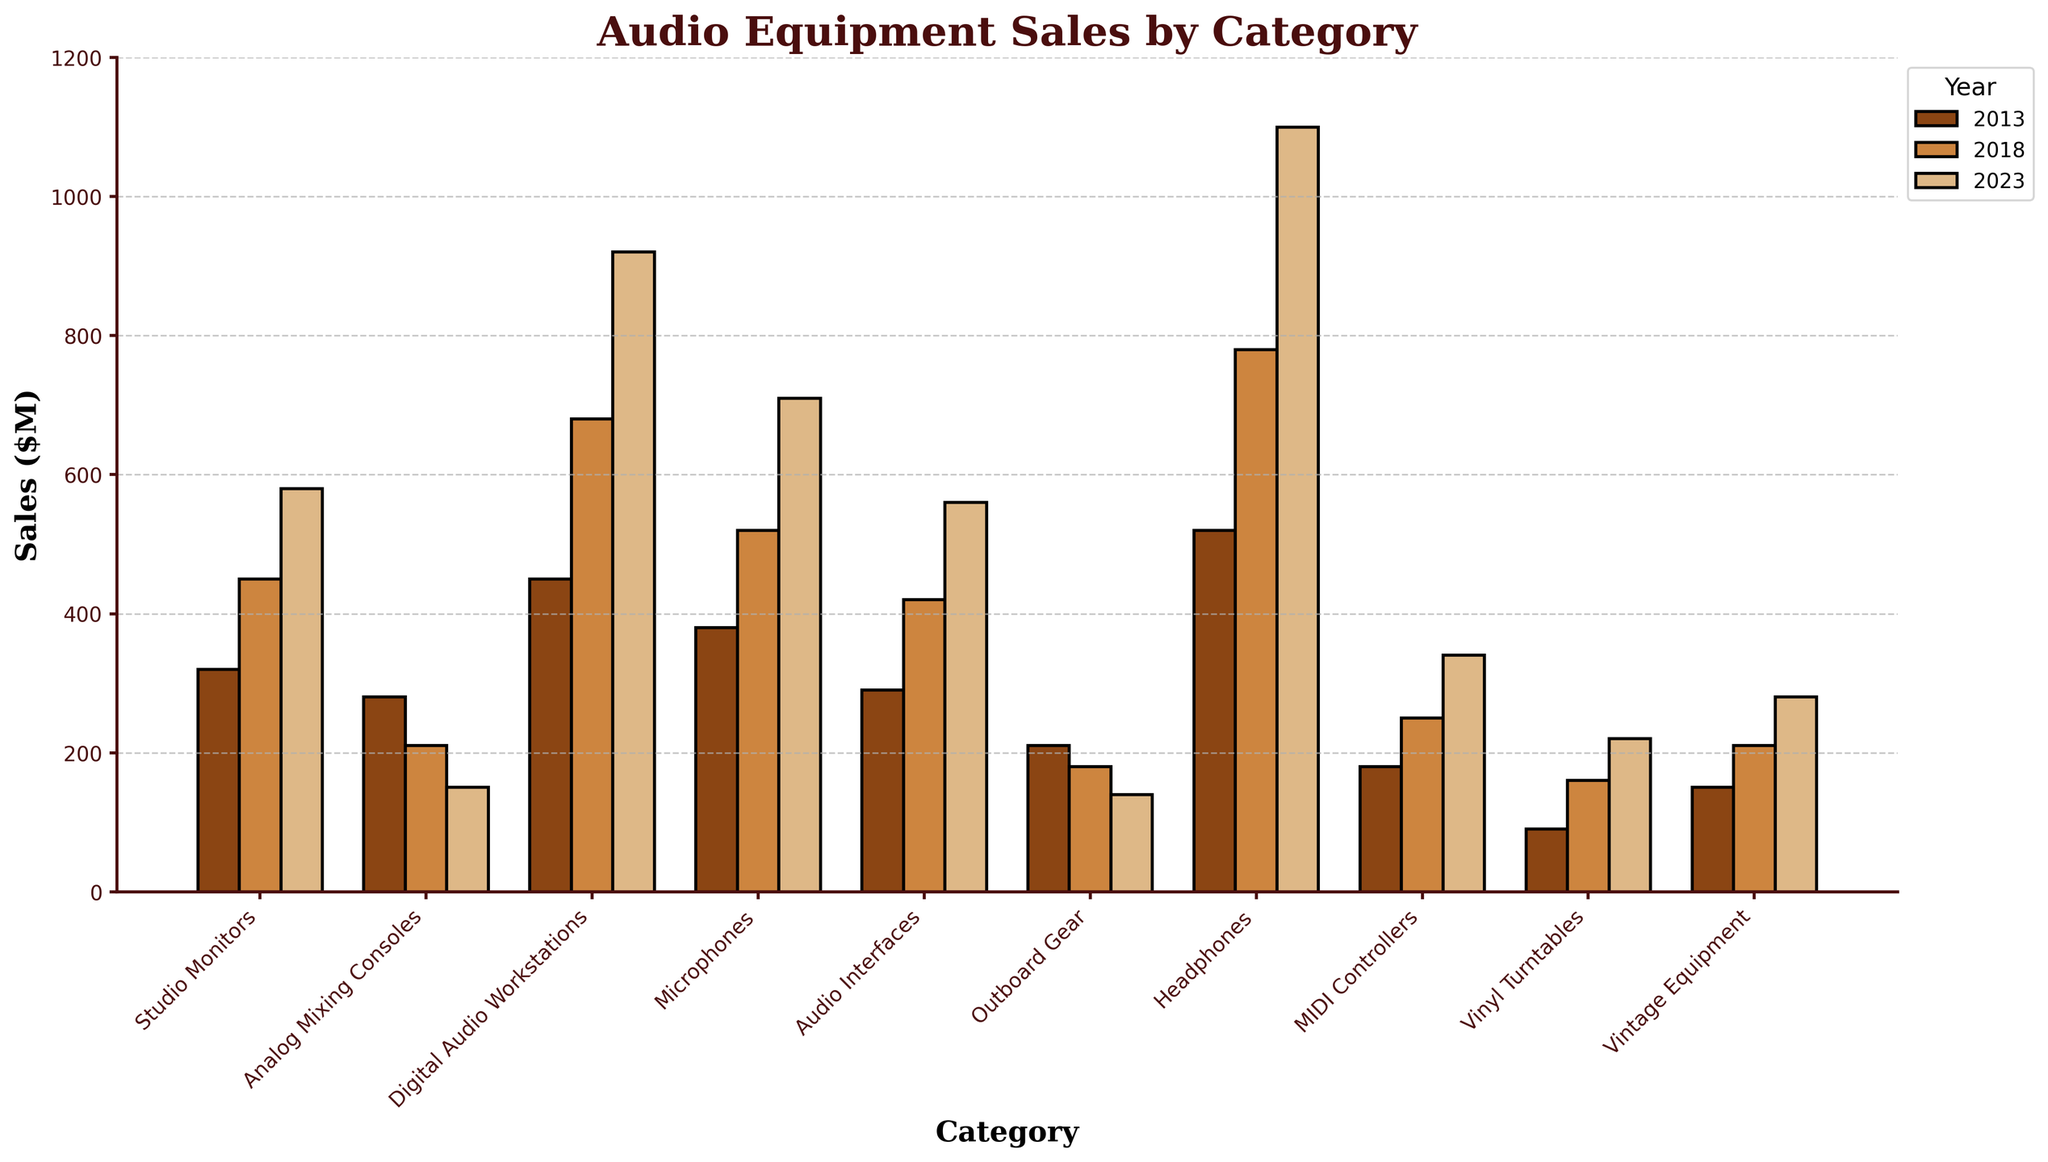What category had the highest sales in 2023? To find the category with the highest sales in 2023, look at the height of the bars for 2023 and identify the tallest one. The highest bar corresponds to Headphones.
Answer: Headphones Which category showed the largest absolute increase in sales from 2013 to 2023? Calculate the difference in sales from 2013 to 2023 for each category, then compare these values to identify the largest increase. The largest increase is from 520M to 1100M for Headphones, i.e., a 580M increase.
Answer: Headphones How did the sales of Analog Mixing Consoles change over the years? Observe the height of the bars for Analog Mixing Consoles over the years. In 2013, the sales were high, but they decreased steadily in 2018 and 2023.
Answer: Decreased Compare the 2023 sales of Digital Audio Workstations to Vintage Equipment. Which category sold more? Look at the height of the bars for Digital Audio Workstations and Vintage Equipment in 2023. The bar for Digital Audio Workstations is higher, indicating higher sales.
Answer: Digital Audio Workstations What is the sum of sales of Audio Interfaces and Microphones in 2023? Add the sales figures for Audio Interfaces (560M) and Microphones (710M) in 2023. The sum is 560M + 710M = 1270M.
Answer: 1270M Which category had the least sales in 2013? Identify the shortest bar in the 2013 data. The shortest bar corresponds to Vinyl Turntables.
Answer: Vinyl Turntables Between 2013 and 2018, which category saw a decrease in sales? Compare the heights of the bars in 2013 and 2018 for each category. Categories like Analog Mixing Consoles and Outboard Gear show a decrease in height.
Answer: Analog Mixing Consoles, Outboard Gear How do the 2023 sales of Studio Monitors compare to those of Audio Interfaces? Compare the height of the bars for Studio Monitors and Audio Interfaces in 2023. The Studio Monitors bar is taller than the Audio Interfaces bar, indicating higher sales.
Answer: Higher Which category had the second highest sales in 2018? Identify the bars representing 2018 and find the second tallest one. Microphones is the second tallest bar standing just after Headphones.
Answer: Microphones What is the average sales of MIDI Controllers over the three years? Sum the sales of MIDI Controllers for 2013 (180M), 2018 (250M), and 2023 (340M) and divide by 3. The average is (180M + 250M + 340M)/3 = 770M/3 ≈ 256.7M.
Answer: 256.7M 